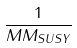Convert formula to latex. <formula><loc_0><loc_0><loc_500><loc_500>\frac { 1 } { M M _ { S U S Y } }</formula> 